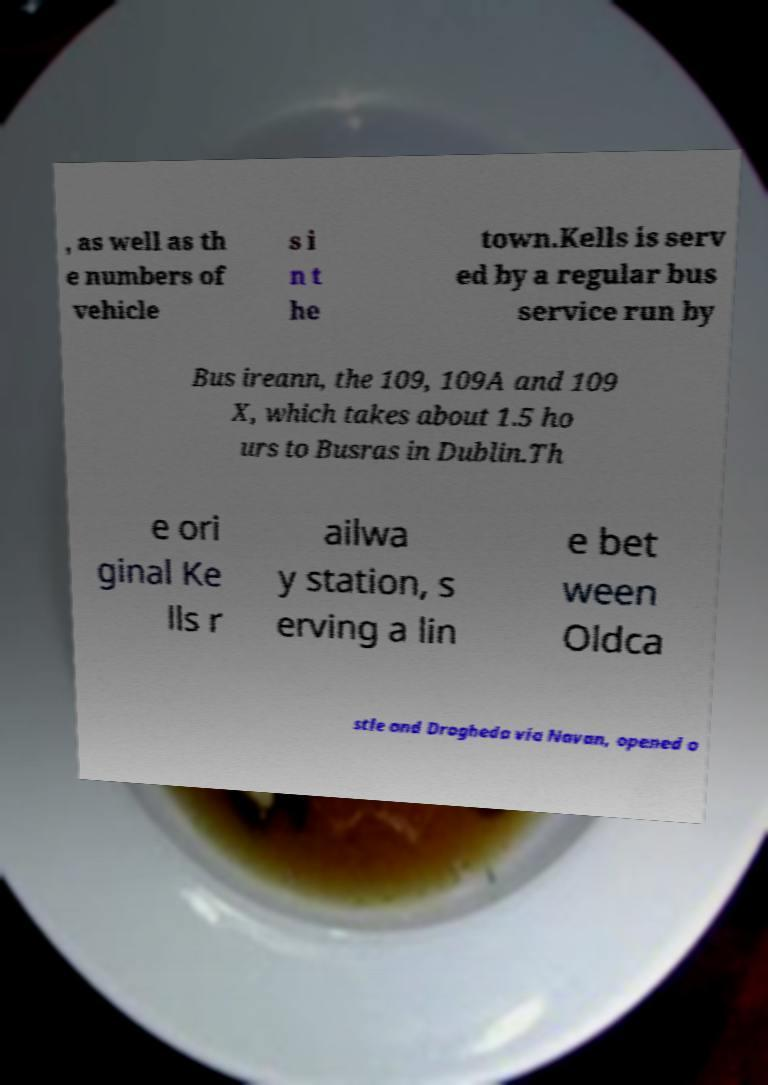Can you accurately transcribe the text from the provided image for me? , as well as th e numbers of vehicle s i n t he town.Kells is serv ed by a regular bus service run by Bus ireann, the 109, 109A and 109 X, which takes about 1.5 ho urs to Busras in Dublin.Th e ori ginal Ke lls r ailwa y station, s erving a lin e bet ween Oldca stle and Drogheda via Navan, opened o 